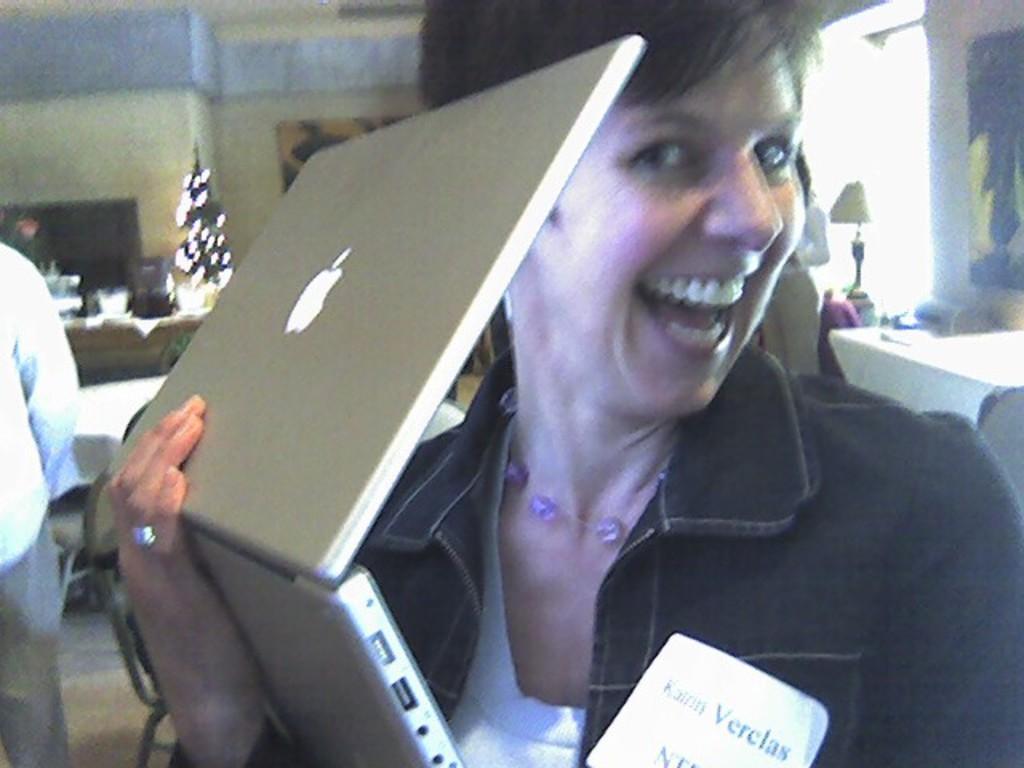Can you describe this image briefly? This image consists of a woman wearing blue jacket and holding a laptop. In the background, there are tables and chairs. To the right, there is a wall along with window. 